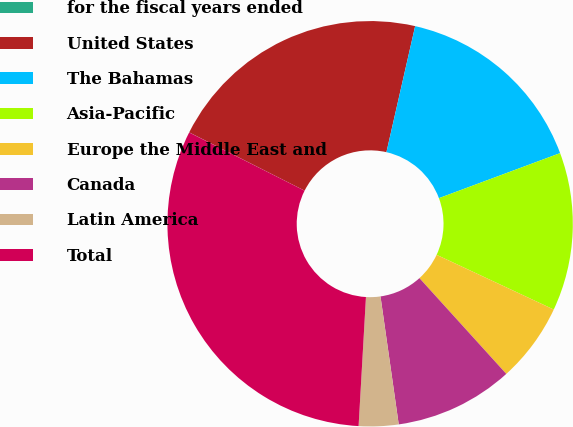Convert chart to OTSL. <chart><loc_0><loc_0><loc_500><loc_500><pie_chart><fcel>for the fiscal years ended<fcel>United States<fcel>The Bahamas<fcel>Asia-Pacific<fcel>Europe the Middle East and<fcel>Canada<fcel>Latin America<fcel>Total<nl><fcel>0.01%<fcel>21.12%<fcel>15.77%<fcel>12.62%<fcel>6.32%<fcel>9.47%<fcel>3.16%<fcel>31.53%<nl></chart> 